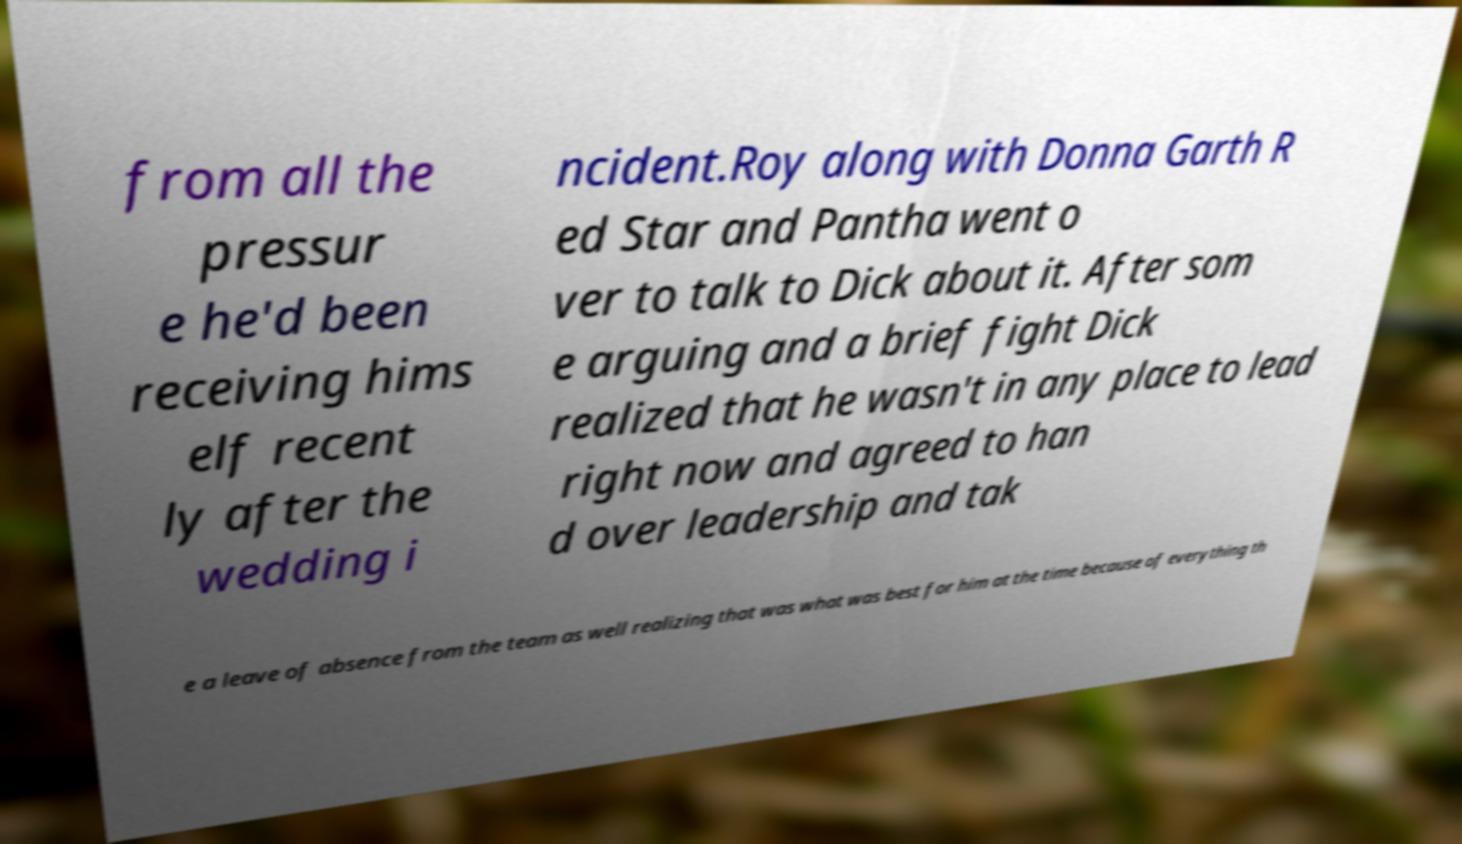There's text embedded in this image that I need extracted. Can you transcribe it verbatim? from all the pressur e he'd been receiving hims elf recent ly after the wedding i ncident.Roy along with Donna Garth R ed Star and Pantha went o ver to talk to Dick about it. After som e arguing and a brief fight Dick realized that he wasn't in any place to lead right now and agreed to han d over leadership and tak e a leave of absence from the team as well realizing that was what was best for him at the time because of everything th 